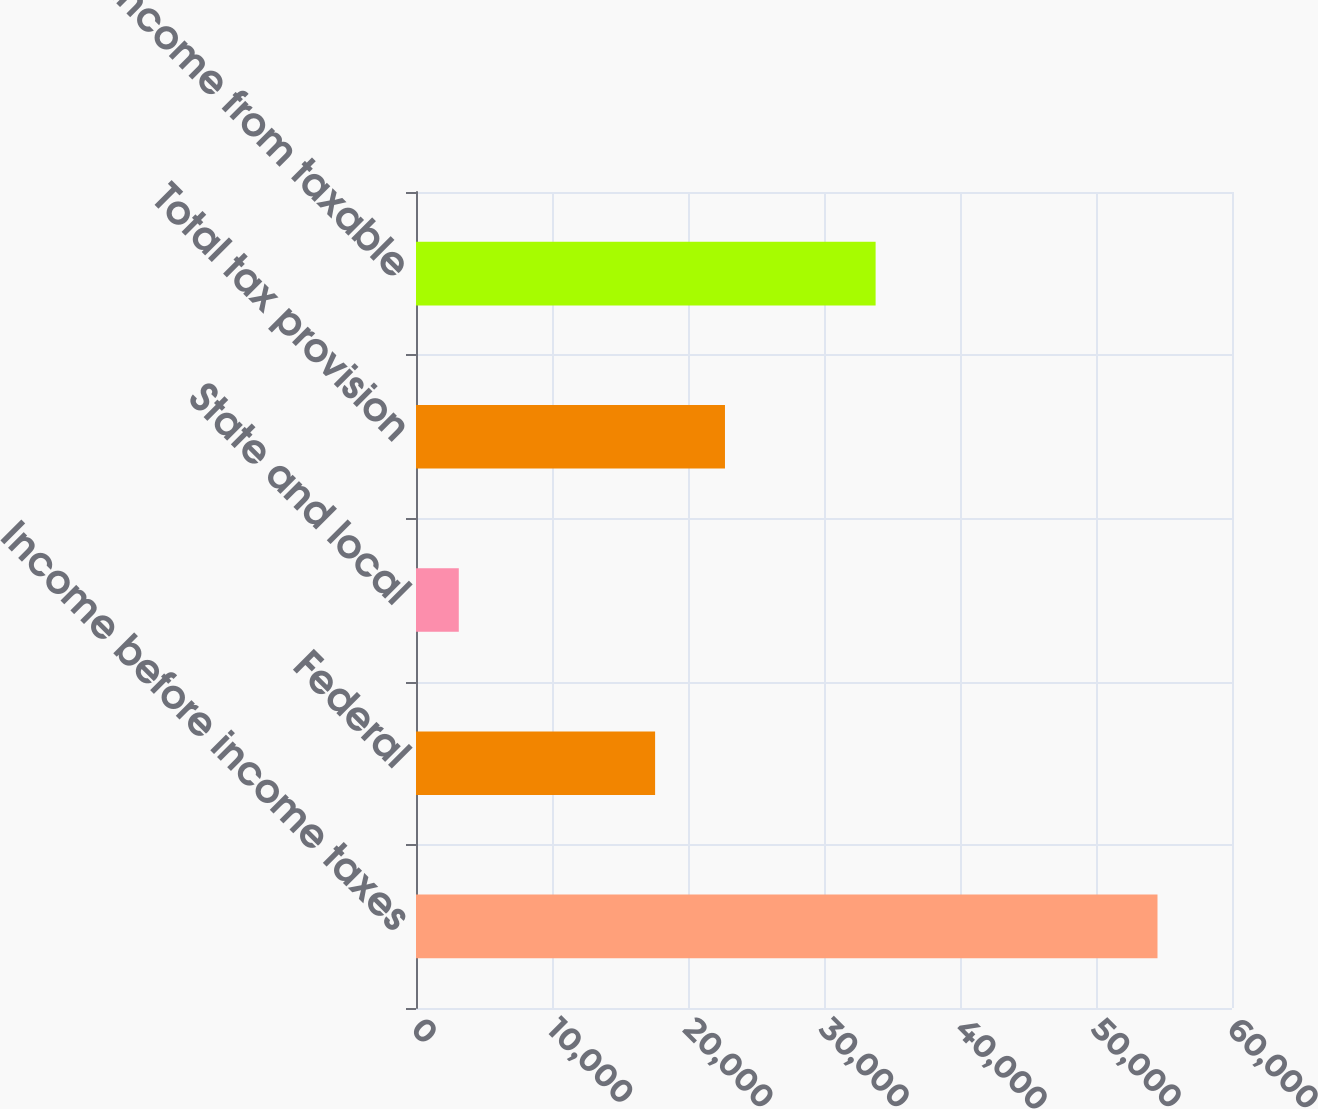Convert chart to OTSL. <chart><loc_0><loc_0><loc_500><loc_500><bar_chart><fcel>Income before income taxes<fcel>Federal<fcel>State and local<fcel>Total tax provision<fcel>GAAP net income from taxable<nl><fcel>54522<fcel>17581<fcel>3146<fcel>22718.6<fcel>33795<nl></chart> 